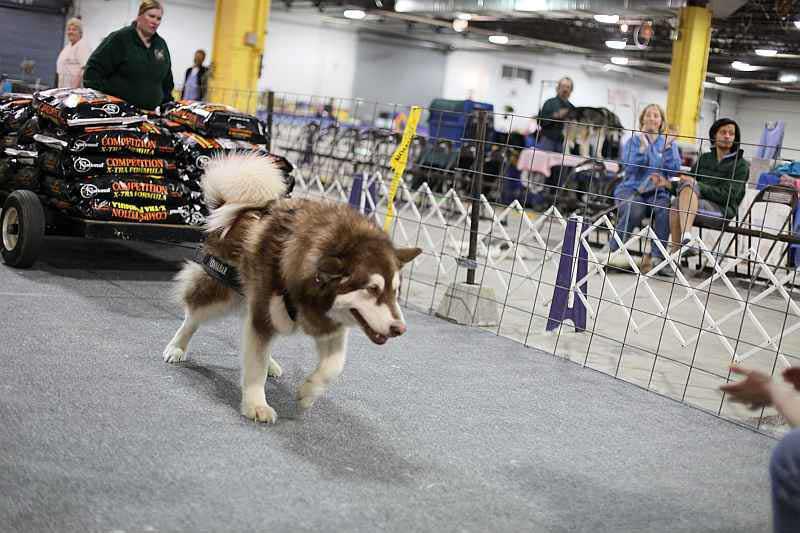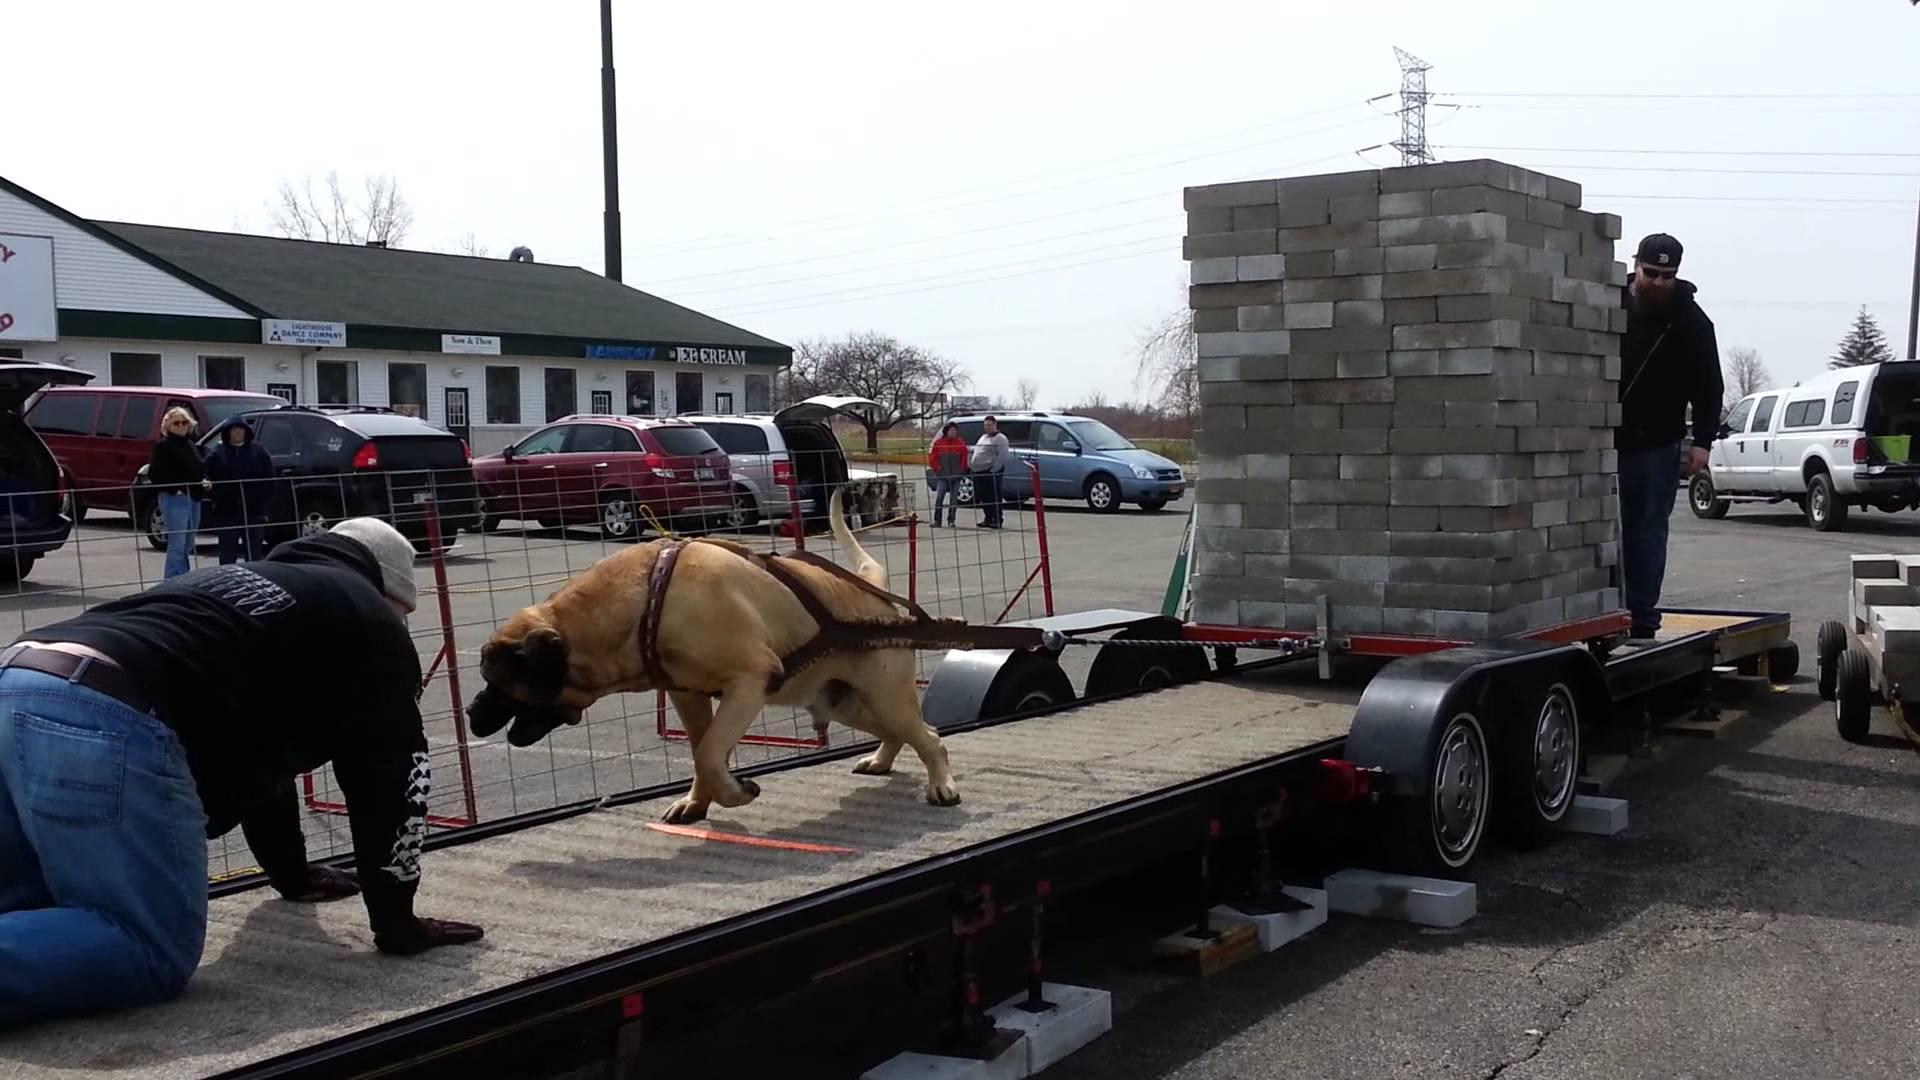The first image is the image on the left, the second image is the image on the right. Considering the images on both sides, is "In at least one image there is a single dog facing left that is trying to pull a stack of cement bricks." valid? Answer yes or no. Yes. The first image is the image on the left, the second image is the image on the right. For the images shown, is this caption "At least one of the dogs in the image on the left is wearing a vest." true? Answer yes or no. No. 